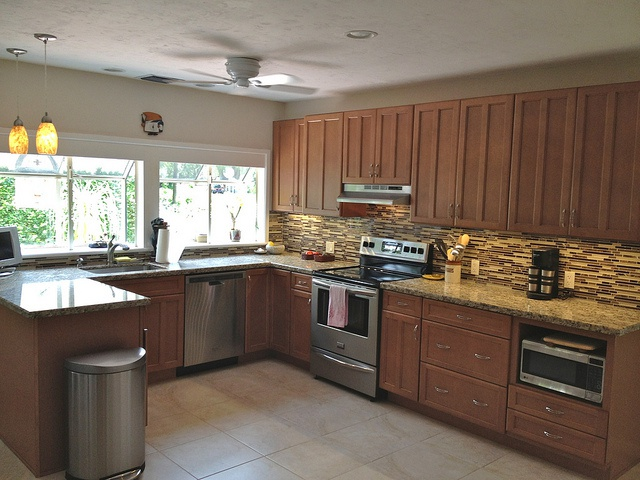Describe the objects in this image and their specific colors. I can see oven in gray, black, and darkgray tones, microwave in gray and black tones, tv in gray and black tones, sink in gray, black, and darkgray tones, and potted plant in gray, white, darkgray, and beige tones in this image. 